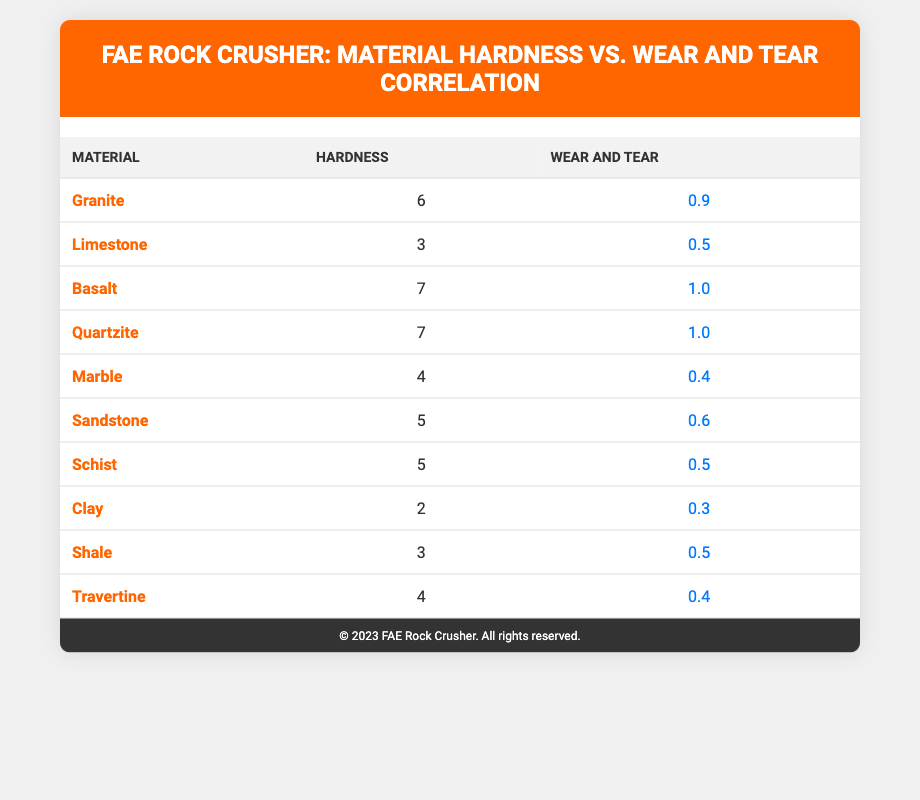What is the hardness value of Basalt? The table lists the hardness for each material. By looking at the row for Basalt, we can see that its hardness value is 7.
Answer: 7 Which material has the lowest wear and tear value? The wear and tear values for each material are listed in the table. By comparing these values, Clay has the lowest wear and tear value at 0.3.
Answer: Clay What is the average hardness of the listed materials? There are 10 materials with their hardness values: 6, 3, 7, 7, 4, 5, 5, 2, 3, and 4. Adding these together gives a total of 46. To find the average, divide 46 by 10, resulting in 4.6.
Answer: 4.6 Is the wear and tear value of Marble greater than 0.5? Looking at the table, the wear and tear value for Marble is 0.4, which is not greater than 0.5. Therefore, the answer is no.
Answer: No What is the difference in wear and tear between Granite and Limestone? The wear and tear values for Granite and Limestone are 0.9 and 0.5, respectively. The difference is calculated as 0.9 - 0.5, which results in a difference of 0.4.
Answer: 0.4 Which materials share the same hardness of 5, and what are their wear and tear values? The table indicates that both Sandstone and Schist have a hardness of 5. Their wear and tear values are 0.6 for Sandstone and 0.5 for Schist.
Answer: Sandstone: 0.6, Schist: 0.5 What is the total wear and tear for all materials with a hardness greater than 5? The materials with a hardness greater than 5 are Basalt and Quartzite, both with a hardness of 7. Their wear and tear values are 1.0 each. Adding these values together gives 1.0 + 1.0 = 2.0.
Answer: 2.0 Is it true that all materials with hardness less than 4 have a wear and tear value lower than 0.5? The materials with hardness less than 4 are Clay (2) and Limestone (3). Their wear and tear values are 0.3 and 0.5, respectively. Since Limestone has a wear and tear value equal to 0.5, the statement is false.
Answer: No What is the median hardness value of the materials listed? To find the median, first list the hardness values in ascending order: 2, 3, 3, 4, 4, 5, 5, 6, 7, 7. With 10 values, the median is the average of the 5th and 6th values (4 and 5), which is (4 + 5) / 2 = 4.5.
Answer: 4.5 